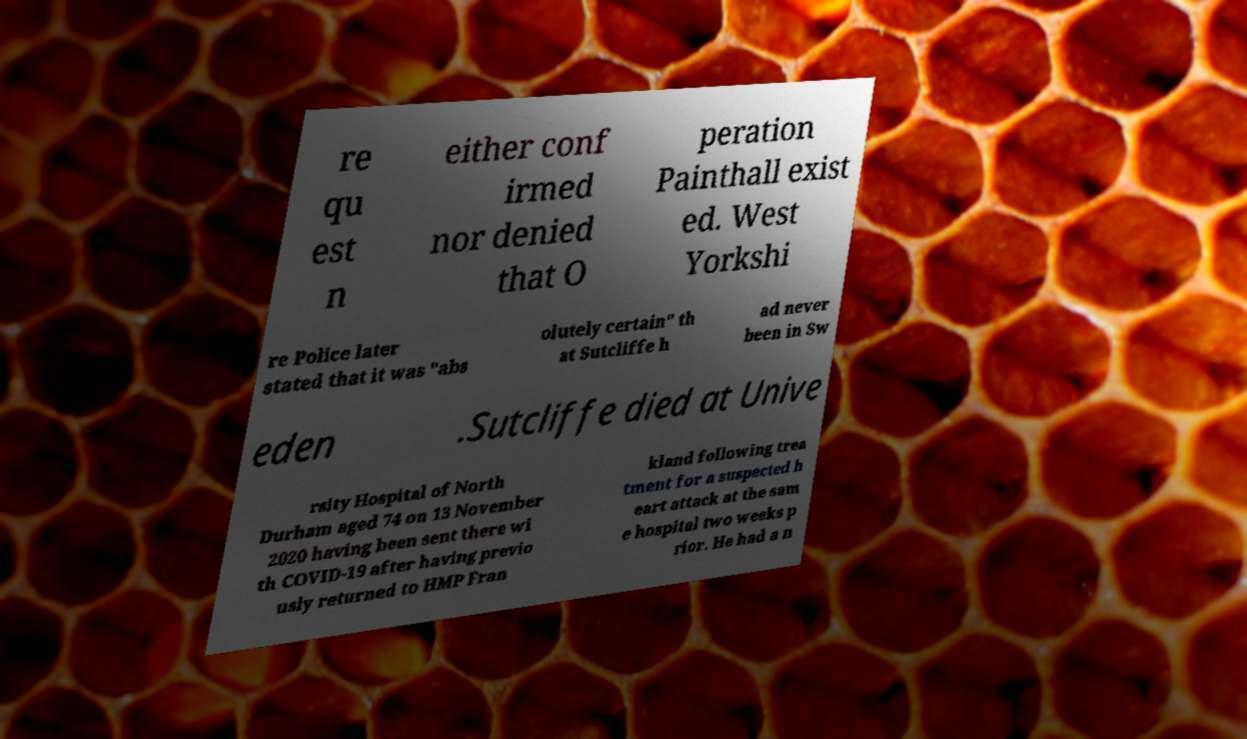Can you read and provide the text displayed in the image?This photo seems to have some interesting text. Can you extract and type it out for me? re qu est n either conf irmed nor denied that O peration Painthall exist ed. West Yorkshi re Police later stated that it was "abs olutely certain" th at Sutcliffe h ad never been in Sw eden .Sutcliffe died at Unive rsity Hospital of North Durham aged 74 on 13 November 2020 having been sent there wi th COVID-19 after having previo usly returned to HMP Fran kland following trea tment for a suspected h eart attack at the sam e hospital two weeks p rior. He had a n 